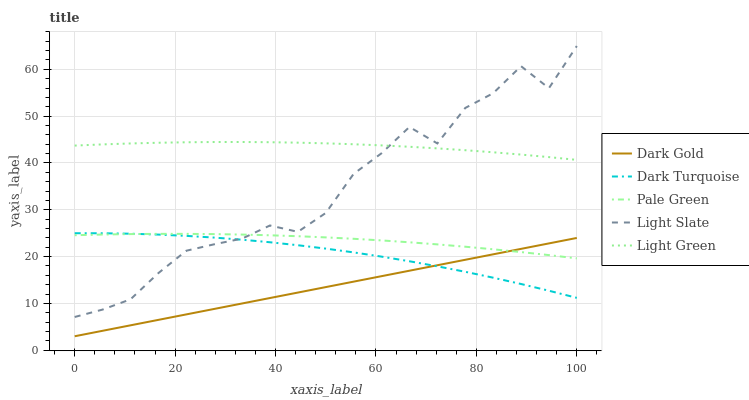Does Dark Gold have the minimum area under the curve?
Answer yes or no. Yes. Does Light Green have the maximum area under the curve?
Answer yes or no. Yes. Does Dark Turquoise have the minimum area under the curve?
Answer yes or no. No. Does Dark Turquoise have the maximum area under the curve?
Answer yes or no. No. Is Dark Gold the smoothest?
Answer yes or no. Yes. Is Light Slate the roughest?
Answer yes or no. Yes. Is Dark Turquoise the smoothest?
Answer yes or no. No. Is Dark Turquoise the roughest?
Answer yes or no. No. Does Dark Gold have the lowest value?
Answer yes or no. Yes. Does Dark Turquoise have the lowest value?
Answer yes or no. No. Does Light Slate have the highest value?
Answer yes or no. Yes. Does Dark Turquoise have the highest value?
Answer yes or no. No. Is Dark Turquoise less than Light Green?
Answer yes or no. Yes. Is Light Green greater than Dark Gold?
Answer yes or no. Yes. Does Dark Turquoise intersect Pale Green?
Answer yes or no. Yes. Is Dark Turquoise less than Pale Green?
Answer yes or no. No. Is Dark Turquoise greater than Pale Green?
Answer yes or no. No. Does Dark Turquoise intersect Light Green?
Answer yes or no. No. 